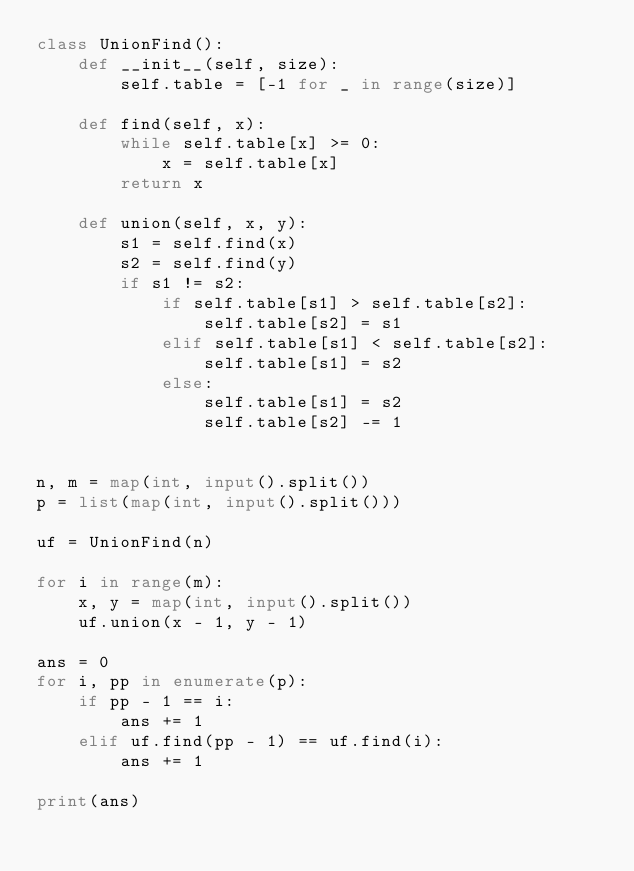Convert code to text. <code><loc_0><loc_0><loc_500><loc_500><_Python_>class UnionFind():
	def __init__(self, size):
		self.table = [-1 for _ in range(size)]

	def find(self, x):
		while self.table[x] >= 0:
			x = self.table[x]
		return x

	def union(self, x, y):
		s1 = self.find(x)
		s2 = self.find(y)
		if s1 != s2:
			if self.table[s1] > self.table[s2]:
				self.table[s2] = s1
			elif self.table[s1] < self.table[s2]:
				self.table[s1] = s2
			else:
				self.table[s1] = s2
				self.table[s2] -= 1


n, m = map(int, input().split())
p = list(map(int, input().split()))

uf = UnionFind(n)

for i in range(m):
	x, y = map(int, input().split())
	uf.union(x - 1, y - 1)

ans = 0
for i, pp in enumerate(p):
	if pp - 1 == i:
		ans += 1
	elif uf.find(pp - 1) == uf.find(i):
		ans += 1

print(ans)</code> 